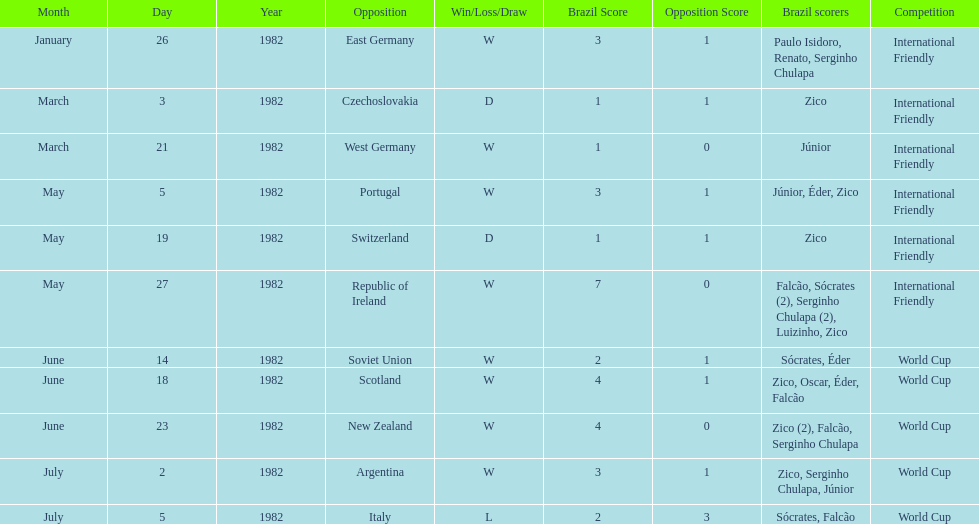Did brazil score more goals against the soviet union or portugal in 1982? Portugal. Can you give me this table as a dict? {'header': ['Month', 'Day', 'Year', 'Opposition', 'Win/Loss/Draw', 'Brazil Score', 'Opposition Score', 'Brazil scorers', 'Competition'], 'rows': [['January', '26', '1982', 'East Germany', 'W', '3', '1', 'Paulo Isidoro, Renato, Serginho Chulapa', 'International Friendly'], ['March', '3', '1982', 'Czechoslovakia', 'D', '1', '1', 'Zico', 'International Friendly'], ['March', '21', '1982', 'West Germany', 'W', '1', '0', 'Júnior', 'International Friendly'], ['May', '5', '1982', 'Portugal', 'W', '3', '1', 'Júnior, Éder, Zico', 'International Friendly'], ['May', '19', '1982', 'Switzerland', 'D', '1', '1', 'Zico', 'International Friendly'], ['May', '27', '1982', 'Republic of Ireland', 'W', '7', '0', 'Falcão, Sócrates (2), Serginho Chulapa (2), Luizinho, Zico', 'International Friendly'], ['June', '14', '1982', 'Soviet Union', 'W', '2', '1', 'Sócrates, Éder', 'World Cup'], ['June', '18', '1982', 'Scotland', 'W', '4', '1', 'Zico, Oscar, Éder, Falcão', 'World Cup'], ['June', '23', '1982', 'New Zealand', 'W', '4', '0', 'Zico (2), Falcão, Serginho Chulapa', 'World Cup'], ['July', '2', '1982', 'Argentina', 'W', '3', '1', 'Zico, Serginho Chulapa, Júnior', 'World Cup'], ['July', '5', '1982', 'Italy', 'L', '2', '3', 'Sócrates, Falcão', 'World Cup']]} 